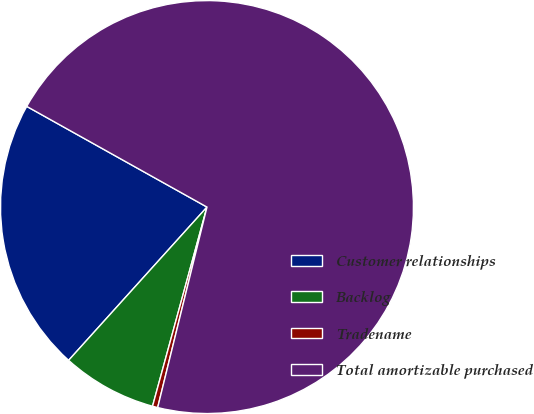Convert chart. <chart><loc_0><loc_0><loc_500><loc_500><pie_chart><fcel>Customer relationships<fcel>Backlog<fcel>Tradename<fcel>Total amortizable purchased<nl><fcel>21.42%<fcel>7.44%<fcel>0.41%<fcel>70.73%<nl></chart> 